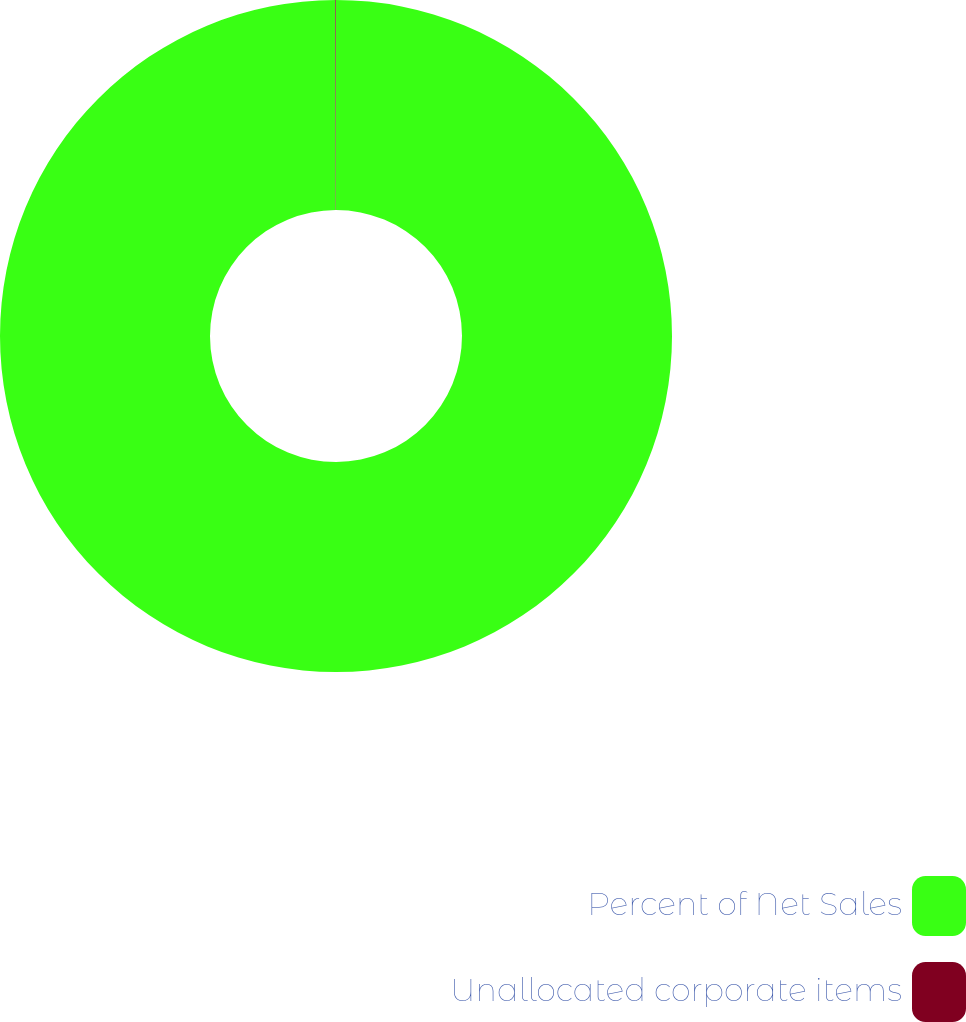Convert chart. <chart><loc_0><loc_0><loc_500><loc_500><pie_chart><fcel>Percent of Net Sales<fcel>Unallocated corporate items<nl><fcel>99.97%<fcel>0.03%<nl></chart> 